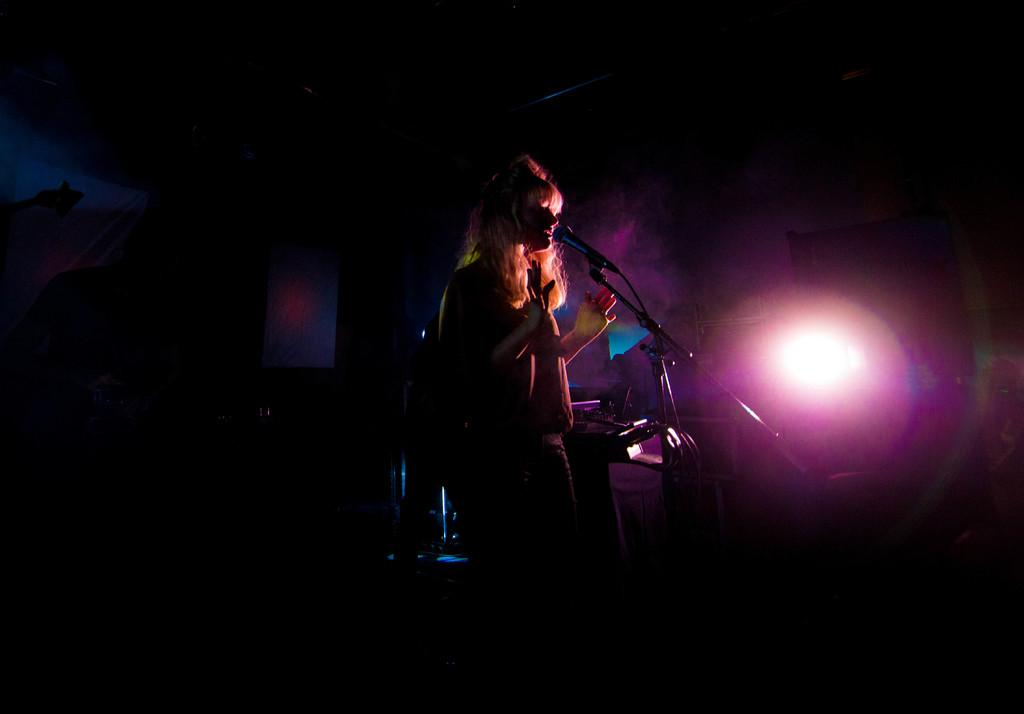Who is the main subject in the image? There is a girl in the image. What is the girl doing in the image? The girl is singing in the image. What object is in front of the girl? There is a microphone in front of the girl. Can you describe the lighting in the room? There is a light passing through the room in the image. How many trees can be seen in the image? There are no trees visible in the image. What type of lift is being used by the girl in the image? There is no lift present in the image; the girl is standing on the ground. 